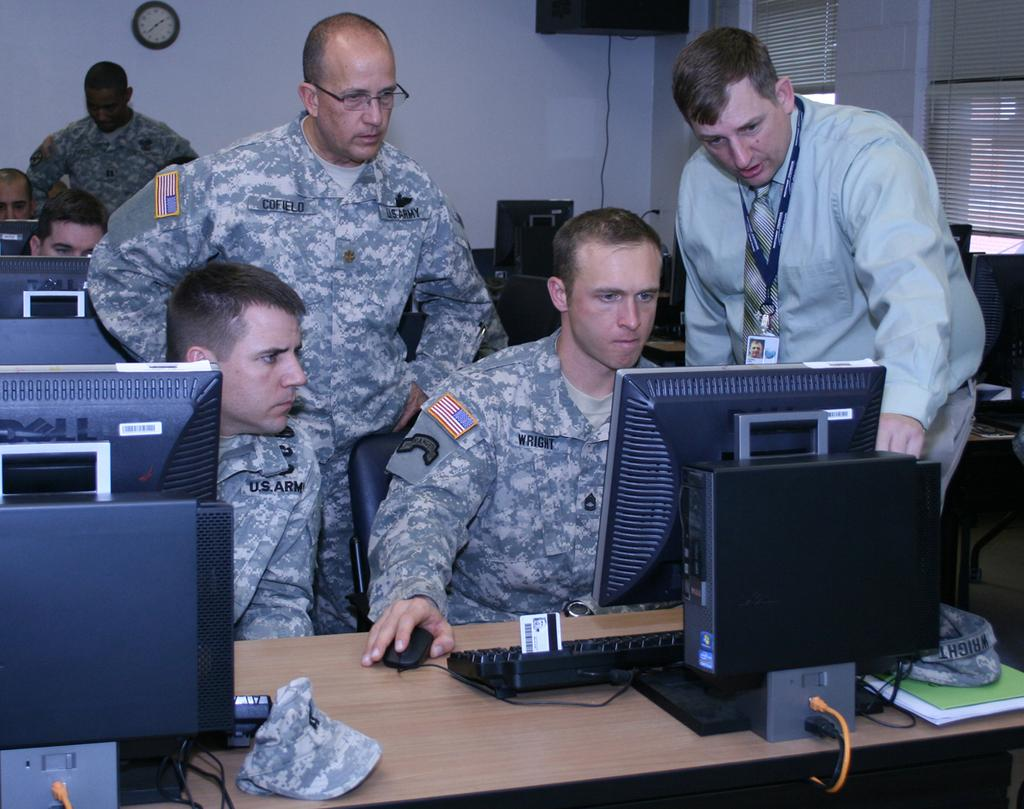<image>
Provide a brief description of the given image. Soldier wearing a U.S. Army outfit looking at the monitor. 